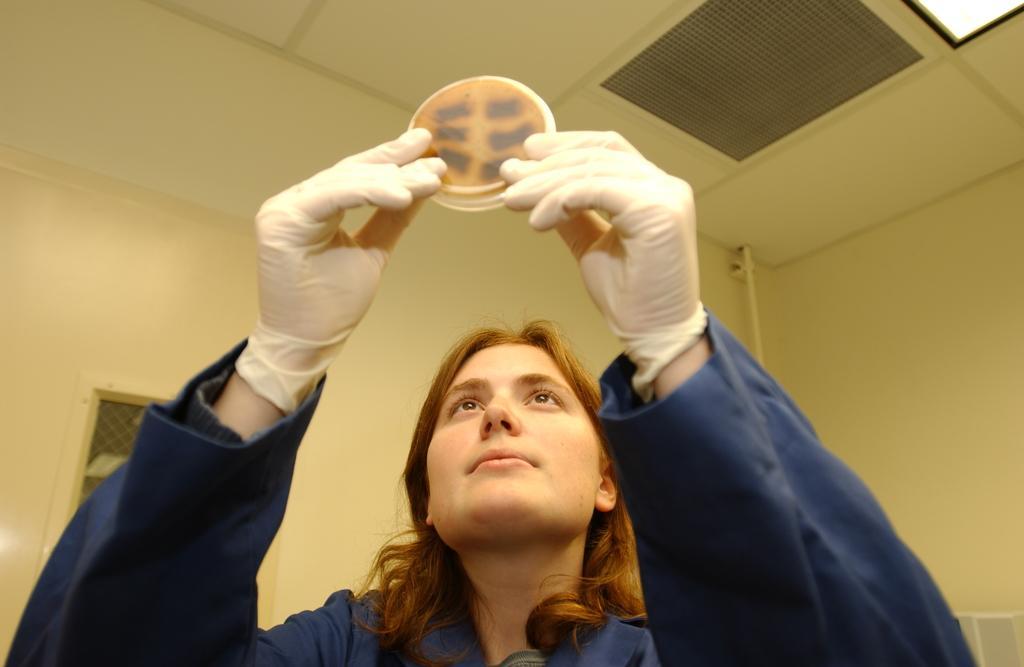How would you summarize this image in a sentence or two? In the image there is a woman, she is holding some object with her hands by wearing gloves, behind the woman there is a wall. 